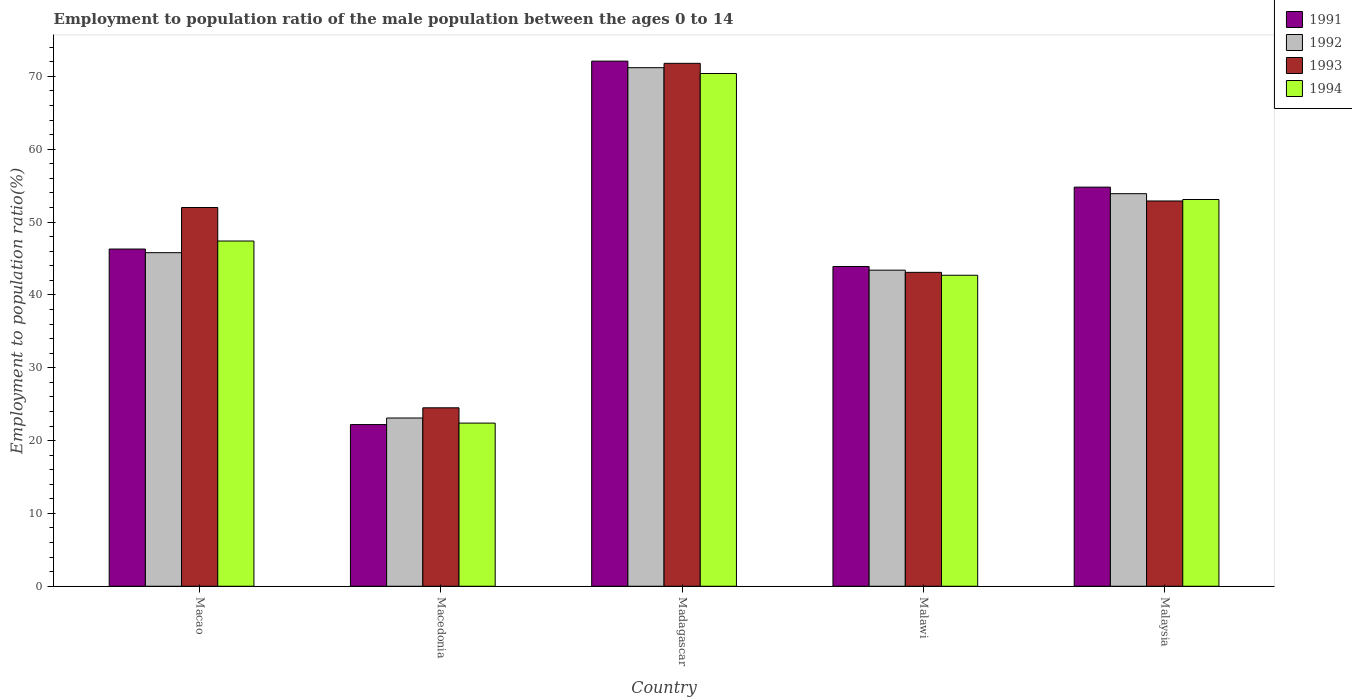Are the number of bars per tick equal to the number of legend labels?
Provide a succinct answer. Yes. Are the number of bars on each tick of the X-axis equal?
Provide a short and direct response. Yes. How many bars are there on the 5th tick from the left?
Provide a short and direct response. 4. How many bars are there on the 1st tick from the right?
Ensure brevity in your answer.  4. What is the label of the 1st group of bars from the left?
Keep it short and to the point. Macao. In how many cases, is the number of bars for a given country not equal to the number of legend labels?
Provide a short and direct response. 0. What is the employment to population ratio in 1994 in Malaysia?
Offer a very short reply. 53.1. Across all countries, what is the maximum employment to population ratio in 1993?
Make the answer very short. 71.8. Across all countries, what is the minimum employment to population ratio in 1991?
Keep it short and to the point. 22.2. In which country was the employment to population ratio in 1993 maximum?
Provide a succinct answer. Madagascar. In which country was the employment to population ratio in 1994 minimum?
Offer a very short reply. Macedonia. What is the total employment to population ratio in 1993 in the graph?
Make the answer very short. 244.3. What is the difference between the employment to population ratio in 1991 in Madagascar and that in Malaysia?
Ensure brevity in your answer.  17.3. What is the difference between the employment to population ratio in 1991 in Malawi and the employment to population ratio in 1994 in Madagascar?
Your answer should be compact. -26.5. What is the average employment to population ratio in 1991 per country?
Ensure brevity in your answer.  47.86. What is the difference between the employment to population ratio of/in 1994 and employment to population ratio of/in 1991 in Malawi?
Keep it short and to the point. -1.2. What is the ratio of the employment to population ratio in 1991 in Macao to that in Malaysia?
Your answer should be very brief. 0.84. Is the employment to population ratio in 1993 in Madagascar less than that in Malawi?
Offer a very short reply. No. Is the difference between the employment to population ratio in 1994 in Macedonia and Madagascar greater than the difference between the employment to population ratio in 1991 in Macedonia and Madagascar?
Your answer should be compact. Yes. What is the difference between the highest and the second highest employment to population ratio in 1994?
Make the answer very short. -17.3. What is the difference between the highest and the lowest employment to population ratio in 1994?
Ensure brevity in your answer.  48. Is the sum of the employment to population ratio in 1993 in Macao and Malaysia greater than the maximum employment to population ratio in 1992 across all countries?
Keep it short and to the point. Yes. What does the 3rd bar from the left in Macao represents?
Your answer should be very brief. 1993. Is it the case that in every country, the sum of the employment to population ratio in 1991 and employment to population ratio in 1992 is greater than the employment to population ratio in 1993?
Keep it short and to the point. Yes. How many countries are there in the graph?
Ensure brevity in your answer.  5. What is the difference between two consecutive major ticks on the Y-axis?
Provide a succinct answer. 10. Are the values on the major ticks of Y-axis written in scientific E-notation?
Give a very brief answer. No. Does the graph contain any zero values?
Provide a short and direct response. No. What is the title of the graph?
Provide a short and direct response. Employment to population ratio of the male population between the ages 0 to 14. What is the label or title of the X-axis?
Your answer should be compact. Country. What is the label or title of the Y-axis?
Your response must be concise. Employment to population ratio(%). What is the Employment to population ratio(%) of 1991 in Macao?
Provide a short and direct response. 46.3. What is the Employment to population ratio(%) of 1992 in Macao?
Offer a very short reply. 45.8. What is the Employment to population ratio(%) of 1994 in Macao?
Your response must be concise. 47.4. What is the Employment to population ratio(%) of 1991 in Macedonia?
Offer a very short reply. 22.2. What is the Employment to population ratio(%) in 1992 in Macedonia?
Provide a succinct answer. 23.1. What is the Employment to population ratio(%) of 1993 in Macedonia?
Give a very brief answer. 24.5. What is the Employment to population ratio(%) in 1994 in Macedonia?
Your response must be concise. 22.4. What is the Employment to population ratio(%) in 1991 in Madagascar?
Provide a succinct answer. 72.1. What is the Employment to population ratio(%) in 1992 in Madagascar?
Keep it short and to the point. 71.2. What is the Employment to population ratio(%) of 1993 in Madagascar?
Ensure brevity in your answer.  71.8. What is the Employment to population ratio(%) of 1994 in Madagascar?
Ensure brevity in your answer.  70.4. What is the Employment to population ratio(%) in 1991 in Malawi?
Make the answer very short. 43.9. What is the Employment to population ratio(%) of 1992 in Malawi?
Ensure brevity in your answer.  43.4. What is the Employment to population ratio(%) of 1993 in Malawi?
Make the answer very short. 43.1. What is the Employment to population ratio(%) in 1994 in Malawi?
Your answer should be very brief. 42.7. What is the Employment to population ratio(%) in 1991 in Malaysia?
Give a very brief answer. 54.8. What is the Employment to population ratio(%) in 1992 in Malaysia?
Make the answer very short. 53.9. What is the Employment to population ratio(%) of 1993 in Malaysia?
Offer a very short reply. 52.9. What is the Employment to population ratio(%) of 1994 in Malaysia?
Provide a short and direct response. 53.1. Across all countries, what is the maximum Employment to population ratio(%) of 1991?
Your response must be concise. 72.1. Across all countries, what is the maximum Employment to population ratio(%) of 1992?
Ensure brevity in your answer.  71.2. Across all countries, what is the maximum Employment to population ratio(%) of 1993?
Your answer should be very brief. 71.8. Across all countries, what is the maximum Employment to population ratio(%) of 1994?
Provide a succinct answer. 70.4. Across all countries, what is the minimum Employment to population ratio(%) in 1991?
Ensure brevity in your answer.  22.2. Across all countries, what is the minimum Employment to population ratio(%) of 1992?
Provide a short and direct response. 23.1. Across all countries, what is the minimum Employment to population ratio(%) in 1994?
Your response must be concise. 22.4. What is the total Employment to population ratio(%) in 1991 in the graph?
Your answer should be compact. 239.3. What is the total Employment to population ratio(%) of 1992 in the graph?
Keep it short and to the point. 237.4. What is the total Employment to population ratio(%) in 1993 in the graph?
Make the answer very short. 244.3. What is the total Employment to population ratio(%) of 1994 in the graph?
Make the answer very short. 236. What is the difference between the Employment to population ratio(%) of 1991 in Macao and that in Macedonia?
Offer a terse response. 24.1. What is the difference between the Employment to population ratio(%) in 1992 in Macao and that in Macedonia?
Ensure brevity in your answer.  22.7. What is the difference between the Employment to population ratio(%) of 1993 in Macao and that in Macedonia?
Provide a succinct answer. 27.5. What is the difference between the Employment to population ratio(%) of 1994 in Macao and that in Macedonia?
Keep it short and to the point. 25. What is the difference between the Employment to population ratio(%) of 1991 in Macao and that in Madagascar?
Ensure brevity in your answer.  -25.8. What is the difference between the Employment to population ratio(%) of 1992 in Macao and that in Madagascar?
Provide a succinct answer. -25.4. What is the difference between the Employment to population ratio(%) in 1993 in Macao and that in Madagascar?
Make the answer very short. -19.8. What is the difference between the Employment to population ratio(%) in 1994 in Macao and that in Madagascar?
Provide a short and direct response. -23. What is the difference between the Employment to population ratio(%) in 1991 in Macao and that in Malawi?
Your response must be concise. 2.4. What is the difference between the Employment to population ratio(%) in 1992 in Macao and that in Malawi?
Keep it short and to the point. 2.4. What is the difference between the Employment to population ratio(%) in 1992 in Macao and that in Malaysia?
Give a very brief answer. -8.1. What is the difference between the Employment to population ratio(%) of 1991 in Macedonia and that in Madagascar?
Give a very brief answer. -49.9. What is the difference between the Employment to population ratio(%) in 1992 in Macedonia and that in Madagascar?
Provide a succinct answer. -48.1. What is the difference between the Employment to population ratio(%) of 1993 in Macedonia and that in Madagascar?
Offer a terse response. -47.3. What is the difference between the Employment to population ratio(%) of 1994 in Macedonia and that in Madagascar?
Give a very brief answer. -48. What is the difference between the Employment to population ratio(%) of 1991 in Macedonia and that in Malawi?
Give a very brief answer. -21.7. What is the difference between the Employment to population ratio(%) of 1992 in Macedonia and that in Malawi?
Your response must be concise. -20.3. What is the difference between the Employment to population ratio(%) in 1993 in Macedonia and that in Malawi?
Provide a succinct answer. -18.6. What is the difference between the Employment to population ratio(%) of 1994 in Macedonia and that in Malawi?
Offer a terse response. -20.3. What is the difference between the Employment to population ratio(%) in 1991 in Macedonia and that in Malaysia?
Keep it short and to the point. -32.6. What is the difference between the Employment to population ratio(%) in 1992 in Macedonia and that in Malaysia?
Offer a terse response. -30.8. What is the difference between the Employment to population ratio(%) of 1993 in Macedonia and that in Malaysia?
Give a very brief answer. -28.4. What is the difference between the Employment to population ratio(%) in 1994 in Macedonia and that in Malaysia?
Ensure brevity in your answer.  -30.7. What is the difference between the Employment to population ratio(%) of 1991 in Madagascar and that in Malawi?
Provide a short and direct response. 28.2. What is the difference between the Employment to population ratio(%) of 1992 in Madagascar and that in Malawi?
Ensure brevity in your answer.  27.8. What is the difference between the Employment to population ratio(%) in 1993 in Madagascar and that in Malawi?
Your answer should be compact. 28.7. What is the difference between the Employment to population ratio(%) in 1994 in Madagascar and that in Malawi?
Keep it short and to the point. 27.7. What is the difference between the Employment to population ratio(%) in 1991 in Madagascar and that in Malaysia?
Make the answer very short. 17.3. What is the difference between the Employment to population ratio(%) of 1992 in Madagascar and that in Malaysia?
Offer a very short reply. 17.3. What is the difference between the Employment to population ratio(%) of 1994 in Madagascar and that in Malaysia?
Offer a terse response. 17.3. What is the difference between the Employment to population ratio(%) in 1991 in Macao and the Employment to population ratio(%) in 1992 in Macedonia?
Keep it short and to the point. 23.2. What is the difference between the Employment to population ratio(%) in 1991 in Macao and the Employment to population ratio(%) in 1993 in Macedonia?
Ensure brevity in your answer.  21.8. What is the difference between the Employment to population ratio(%) of 1991 in Macao and the Employment to population ratio(%) of 1994 in Macedonia?
Make the answer very short. 23.9. What is the difference between the Employment to population ratio(%) in 1992 in Macao and the Employment to population ratio(%) in 1993 in Macedonia?
Your answer should be compact. 21.3. What is the difference between the Employment to population ratio(%) of 1992 in Macao and the Employment to population ratio(%) of 1994 in Macedonia?
Your answer should be compact. 23.4. What is the difference between the Employment to population ratio(%) in 1993 in Macao and the Employment to population ratio(%) in 1994 in Macedonia?
Offer a terse response. 29.6. What is the difference between the Employment to population ratio(%) of 1991 in Macao and the Employment to population ratio(%) of 1992 in Madagascar?
Ensure brevity in your answer.  -24.9. What is the difference between the Employment to population ratio(%) of 1991 in Macao and the Employment to population ratio(%) of 1993 in Madagascar?
Your response must be concise. -25.5. What is the difference between the Employment to population ratio(%) in 1991 in Macao and the Employment to population ratio(%) in 1994 in Madagascar?
Ensure brevity in your answer.  -24.1. What is the difference between the Employment to population ratio(%) of 1992 in Macao and the Employment to population ratio(%) of 1994 in Madagascar?
Ensure brevity in your answer.  -24.6. What is the difference between the Employment to population ratio(%) in 1993 in Macao and the Employment to population ratio(%) in 1994 in Madagascar?
Provide a short and direct response. -18.4. What is the difference between the Employment to population ratio(%) of 1992 in Macao and the Employment to population ratio(%) of 1993 in Malawi?
Offer a very short reply. 2.7. What is the difference between the Employment to population ratio(%) in 1992 in Macao and the Employment to population ratio(%) in 1994 in Malawi?
Your response must be concise. 3.1. What is the difference between the Employment to population ratio(%) of 1991 in Macao and the Employment to population ratio(%) of 1992 in Malaysia?
Provide a short and direct response. -7.6. What is the difference between the Employment to population ratio(%) of 1992 in Macao and the Employment to population ratio(%) of 1993 in Malaysia?
Offer a very short reply. -7.1. What is the difference between the Employment to population ratio(%) in 1992 in Macao and the Employment to population ratio(%) in 1994 in Malaysia?
Give a very brief answer. -7.3. What is the difference between the Employment to population ratio(%) in 1993 in Macao and the Employment to population ratio(%) in 1994 in Malaysia?
Provide a succinct answer. -1.1. What is the difference between the Employment to population ratio(%) in 1991 in Macedonia and the Employment to population ratio(%) in 1992 in Madagascar?
Your answer should be very brief. -49. What is the difference between the Employment to population ratio(%) of 1991 in Macedonia and the Employment to population ratio(%) of 1993 in Madagascar?
Your answer should be compact. -49.6. What is the difference between the Employment to population ratio(%) in 1991 in Macedonia and the Employment to population ratio(%) in 1994 in Madagascar?
Provide a short and direct response. -48.2. What is the difference between the Employment to population ratio(%) in 1992 in Macedonia and the Employment to population ratio(%) in 1993 in Madagascar?
Provide a short and direct response. -48.7. What is the difference between the Employment to population ratio(%) of 1992 in Macedonia and the Employment to population ratio(%) of 1994 in Madagascar?
Offer a very short reply. -47.3. What is the difference between the Employment to population ratio(%) of 1993 in Macedonia and the Employment to population ratio(%) of 1994 in Madagascar?
Your response must be concise. -45.9. What is the difference between the Employment to population ratio(%) in 1991 in Macedonia and the Employment to population ratio(%) in 1992 in Malawi?
Provide a succinct answer. -21.2. What is the difference between the Employment to population ratio(%) of 1991 in Macedonia and the Employment to population ratio(%) of 1993 in Malawi?
Keep it short and to the point. -20.9. What is the difference between the Employment to population ratio(%) in 1991 in Macedonia and the Employment to population ratio(%) in 1994 in Malawi?
Make the answer very short. -20.5. What is the difference between the Employment to population ratio(%) of 1992 in Macedonia and the Employment to population ratio(%) of 1994 in Malawi?
Give a very brief answer. -19.6. What is the difference between the Employment to population ratio(%) of 1993 in Macedonia and the Employment to population ratio(%) of 1994 in Malawi?
Provide a succinct answer. -18.2. What is the difference between the Employment to population ratio(%) of 1991 in Macedonia and the Employment to population ratio(%) of 1992 in Malaysia?
Ensure brevity in your answer.  -31.7. What is the difference between the Employment to population ratio(%) in 1991 in Macedonia and the Employment to population ratio(%) in 1993 in Malaysia?
Offer a very short reply. -30.7. What is the difference between the Employment to population ratio(%) in 1991 in Macedonia and the Employment to population ratio(%) in 1994 in Malaysia?
Your response must be concise. -30.9. What is the difference between the Employment to population ratio(%) of 1992 in Macedonia and the Employment to population ratio(%) of 1993 in Malaysia?
Provide a succinct answer. -29.8. What is the difference between the Employment to population ratio(%) of 1993 in Macedonia and the Employment to population ratio(%) of 1994 in Malaysia?
Keep it short and to the point. -28.6. What is the difference between the Employment to population ratio(%) in 1991 in Madagascar and the Employment to population ratio(%) in 1992 in Malawi?
Your response must be concise. 28.7. What is the difference between the Employment to population ratio(%) in 1991 in Madagascar and the Employment to population ratio(%) in 1993 in Malawi?
Your response must be concise. 29. What is the difference between the Employment to population ratio(%) of 1991 in Madagascar and the Employment to population ratio(%) of 1994 in Malawi?
Keep it short and to the point. 29.4. What is the difference between the Employment to population ratio(%) of 1992 in Madagascar and the Employment to population ratio(%) of 1993 in Malawi?
Offer a very short reply. 28.1. What is the difference between the Employment to population ratio(%) in 1992 in Madagascar and the Employment to population ratio(%) in 1994 in Malawi?
Give a very brief answer. 28.5. What is the difference between the Employment to population ratio(%) of 1993 in Madagascar and the Employment to population ratio(%) of 1994 in Malawi?
Provide a short and direct response. 29.1. What is the difference between the Employment to population ratio(%) of 1991 in Madagascar and the Employment to population ratio(%) of 1992 in Malaysia?
Make the answer very short. 18.2. What is the difference between the Employment to population ratio(%) of 1991 in Madagascar and the Employment to population ratio(%) of 1994 in Malaysia?
Your answer should be compact. 19. What is the difference between the Employment to population ratio(%) in 1993 in Madagascar and the Employment to population ratio(%) in 1994 in Malaysia?
Your response must be concise. 18.7. What is the difference between the Employment to population ratio(%) in 1992 in Malawi and the Employment to population ratio(%) in 1994 in Malaysia?
Keep it short and to the point. -9.7. What is the difference between the Employment to population ratio(%) in 1993 in Malawi and the Employment to population ratio(%) in 1994 in Malaysia?
Keep it short and to the point. -10. What is the average Employment to population ratio(%) in 1991 per country?
Offer a terse response. 47.86. What is the average Employment to population ratio(%) of 1992 per country?
Offer a very short reply. 47.48. What is the average Employment to population ratio(%) of 1993 per country?
Provide a short and direct response. 48.86. What is the average Employment to population ratio(%) of 1994 per country?
Provide a short and direct response. 47.2. What is the difference between the Employment to population ratio(%) of 1991 and Employment to population ratio(%) of 1993 in Macao?
Your answer should be very brief. -5.7. What is the difference between the Employment to population ratio(%) in 1991 and Employment to population ratio(%) in 1994 in Macao?
Ensure brevity in your answer.  -1.1. What is the difference between the Employment to population ratio(%) in 1992 and Employment to population ratio(%) in 1993 in Macao?
Your answer should be very brief. -6.2. What is the difference between the Employment to population ratio(%) of 1991 and Employment to population ratio(%) of 1992 in Macedonia?
Ensure brevity in your answer.  -0.9. What is the difference between the Employment to population ratio(%) in 1991 and Employment to population ratio(%) in 1994 in Macedonia?
Your answer should be compact. -0.2. What is the difference between the Employment to population ratio(%) of 1991 and Employment to population ratio(%) of 1992 in Madagascar?
Give a very brief answer. 0.9. What is the difference between the Employment to population ratio(%) of 1991 and Employment to population ratio(%) of 1993 in Madagascar?
Your response must be concise. 0.3. What is the difference between the Employment to population ratio(%) in 1992 and Employment to population ratio(%) in 1993 in Madagascar?
Make the answer very short. -0.6. What is the difference between the Employment to population ratio(%) of 1992 and Employment to population ratio(%) of 1994 in Madagascar?
Offer a terse response. 0.8. What is the difference between the Employment to population ratio(%) of 1993 and Employment to population ratio(%) of 1994 in Madagascar?
Provide a succinct answer. 1.4. What is the difference between the Employment to population ratio(%) in 1991 and Employment to population ratio(%) in 1993 in Malawi?
Provide a short and direct response. 0.8. What is the difference between the Employment to population ratio(%) in 1991 and Employment to population ratio(%) in 1994 in Malawi?
Offer a terse response. 1.2. What is the difference between the Employment to population ratio(%) in 1991 and Employment to population ratio(%) in 1994 in Malaysia?
Your answer should be compact. 1.7. What is the difference between the Employment to population ratio(%) of 1992 and Employment to population ratio(%) of 1993 in Malaysia?
Your answer should be very brief. 1. What is the ratio of the Employment to population ratio(%) in 1991 in Macao to that in Macedonia?
Your response must be concise. 2.09. What is the ratio of the Employment to population ratio(%) in 1992 in Macao to that in Macedonia?
Offer a terse response. 1.98. What is the ratio of the Employment to population ratio(%) of 1993 in Macao to that in Macedonia?
Your answer should be very brief. 2.12. What is the ratio of the Employment to population ratio(%) in 1994 in Macao to that in Macedonia?
Keep it short and to the point. 2.12. What is the ratio of the Employment to population ratio(%) in 1991 in Macao to that in Madagascar?
Offer a terse response. 0.64. What is the ratio of the Employment to population ratio(%) in 1992 in Macao to that in Madagascar?
Offer a very short reply. 0.64. What is the ratio of the Employment to population ratio(%) in 1993 in Macao to that in Madagascar?
Provide a succinct answer. 0.72. What is the ratio of the Employment to population ratio(%) of 1994 in Macao to that in Madagascar?
Give a very brief answer. 0.67. What is the ratio of the Employment to population ratio(%) of 1991 in Macao to that in Malawi?
Provide a succinct answer. 1.05. What is the ratio of the Employment to population ratio(%) of 1992 in Macao to that in Malawi?
Offer a terse response. 1.06. What is the ratio of the Employment to population ratio(%) of 1993 in Macao to that in Malawi?
Your answer should be very brief. 1.21. What is the ratio of the Employment to population ratio(%) of 1994 in Macao to that in Malawi?
Your answer should be compact. 1.11. What is the ratio of the Employment to population ratio(%) of 1991 in Macao to that in Malaysia?
Provide a succinct answer. 0.84. What is the ratio of the Employment to population ratio(%) of 1992 in Macao to that in Malaysia?
Your answer should be very brief. 0.85. What is the ratio of the Employment to population ratio(%) in 1993 in Macao to that in Malaysia?
Offer a terse response. 0.98. What is the ratio of the Employment to population ratio(%) in 1994 in Macao to that in Malaysia?
Your answer should be compact. 0.89. What is the ratio of the Employment to population ratio(%) of 1991 in Macedonia to that in Madagascar?
Offer a terse response. 0.31. What is the ratio of the Employment to population ratio(%) in 1992 in Macedonia to that in Madagascar?
Provide a succinct answer. 0.32. What is the ratio of the Employment to population ratio(%) of 1993 in Macedonia to that in Madagascar?
Ensure brevity in your answer.  0.34. What is the ratio of the Employment to population ratio(%) of 1994 in Macedonia to that in Madagascar?
Make the answer very short. 0.32. What is the ratio of the Employment to population ratio(%) in 1991 in Macedonia to that in Malawi?
Provide a short and direct response. 0.51. What is the ratio of the Employment to population ratio(%) of 1992 in Macedonia to that in Malawi?
Offer a terse response. 0.53. What is the ratio of the Employment to population ratio(%) of 1993 in Macedonia to that in Malawi?
Your response must be concise. 0.57. What is the ratio of the Employment to population ratio(%) of 1994 in Macedonia to that in Malawi?
Your answer should be very brief. 0.52. What is the ratio of the Employment to population ratio(%) in 1991 in Macedonia to that in Malaysia?
Ensure brevity in your answer.  0.41. What is the ratio of the Employment to population ratio(%) of 1992 in Macedonia to that in Malaysia?
Your response must be concise. 0.43. What is the ratio of the Employment to population ratio(%) in 1993 in Macedonia to that in Malaysia?
Offer a terse response. 0.46. What is the ratio of the Employment to population ratio(%) in 1994 in Macedonia to that in Malaysia?
Offer a very short reply. 0.42. What is the ratio of the Employment to population ratio(%) in 1991 in Madagascar to that in Malawi?
Give a very brief answer. 1.64. What is the ratio of the Employment to population ratio(%) in 1992 in Madagascar to that in Malawi?
Offer a terse response. 1.64. What is the ratio of the Employment to population ratio(%) of 1993 in Madagascar to that in Malawi?
Your answer should be very brief. 1.67. What is the ratio of the Employment to population ratio(%) in 1994 in Madagascar to that in Malawi?
Ensure brevity in your answer.  1.65. What is the ratio of the Employment to population ratio(%) in 1991 in Madagascar to that in Malaysia?
Keep it short and to the point. 1.32. What is the ratio of the Employment to population ratio(%) in 1992 in Madagascar to that in Malaysia?
Offer a very short reply. 1.32. What is the ratio of the Employment to population ratio(%) of 1993 in Madagascar to that in Malaysia?
Ensure brevity in your answer.  1.36. What is the ratio of the Employment to population ratio(%) of 1994 in Madagascar to that in Malaysia?
Provide a succinct answer. 1.33. What is the ratio of the Employment to population ratio(%) in 1991 in Malawi to that in Malaysia?
Make the answer very short. 0.8. What is the ratio of the Employment to population ratio(%) in 1992 in Malawi to that in Malaysia?
Keep it short and to the point. 0.81. What is the ratio of the Employment to population ratio(%) of 1993 in Malawi to that in Malaysia?
Offer a very short reply. 0.81. What is the ratio of the Employment to population ratio(%) of 1994 in Malawi to that in Malaysia?
Make the answer very short. 0.8. What is the difference between the highest and the second highest Employment to population ratio(%) in 1992?
Make the answer very short. 17.3. What is the difference between the highest and the second highest Employment to population ratio(%) in 1993?
Provide a short and direct response. 18.9. What is the difference between the highest and the second highest Employment to population ratio(%) of 1994?
Make the answer very short. 17.3. What is the difference between the highest and the lowest Employment to population ratio(%) of 1991?
Offer a terse response. 49.9. What is the difference between the highest and the lowest Employment to population ratio(%) in 1992?
Your answer should be very brief. 48.1. What is the difference between the highest and the lowest Employment to population ratio(%) of 1993?
Offer a terse response. 47.3. What is the difference between the highest and the lowest Employment to population ratio(%) in 1994?
Your answer should be very brief. 48. 